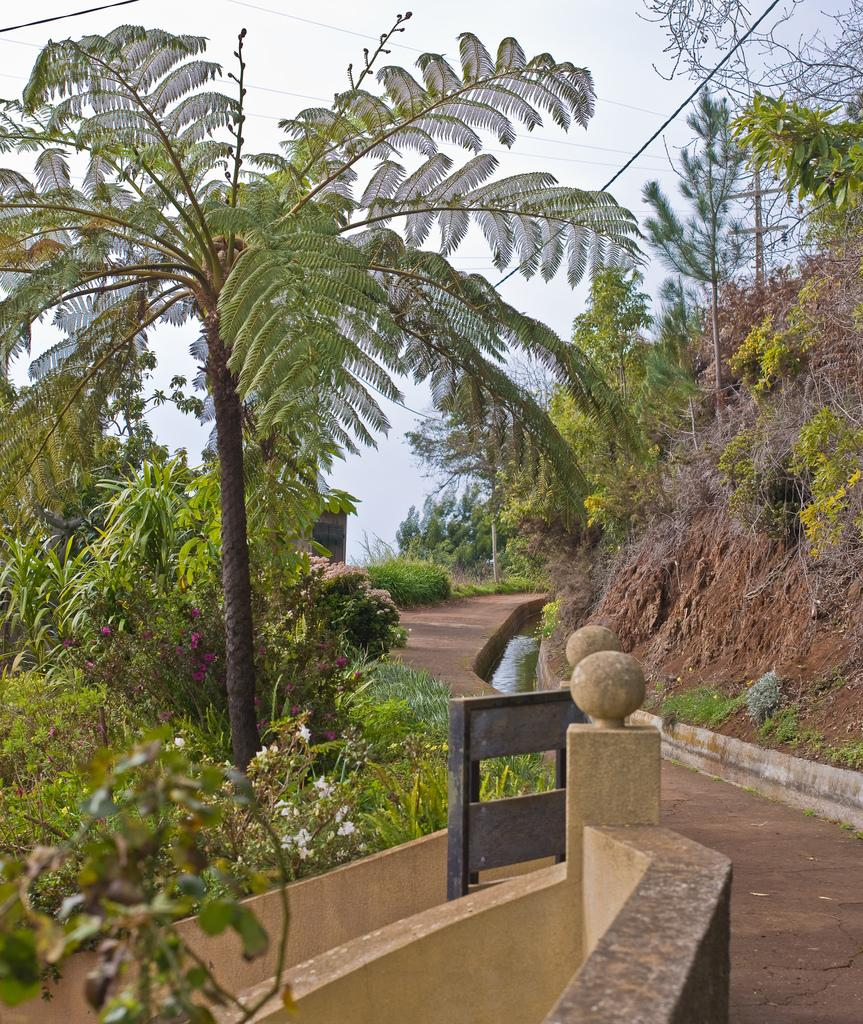What type of living organisms can be seen in the image? Plants, flowers, and trees are visible in the image. What is the natural environment like in the image? The image features plants, flowers, trees, and water. What can be seen in the background of the image? The sky is visible in the background of the image. What type of nerve can be seen in the image? There is no nerve present in the image; it features plants, flowers, trees, water, and the sky. How many chickens are visible in the image? There are no chickens present in the image. 